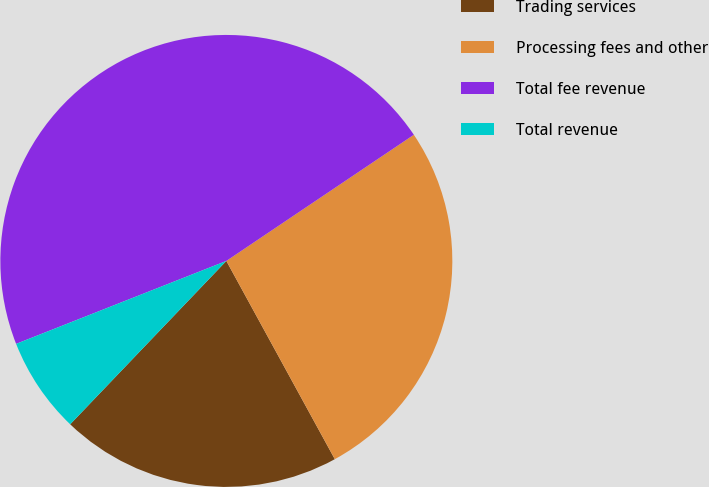<chart> <loc_0><loc_0><loc_500><loc_500><pie_chart><fcel>Trading services<fcel>Processing fees and other<fcel>Total fee revenue<fcel>Total revenue<nl><fcel>20.11%<fcel>26.46%<fcel>46.56%<fcel>6.88%<nl></chart> 